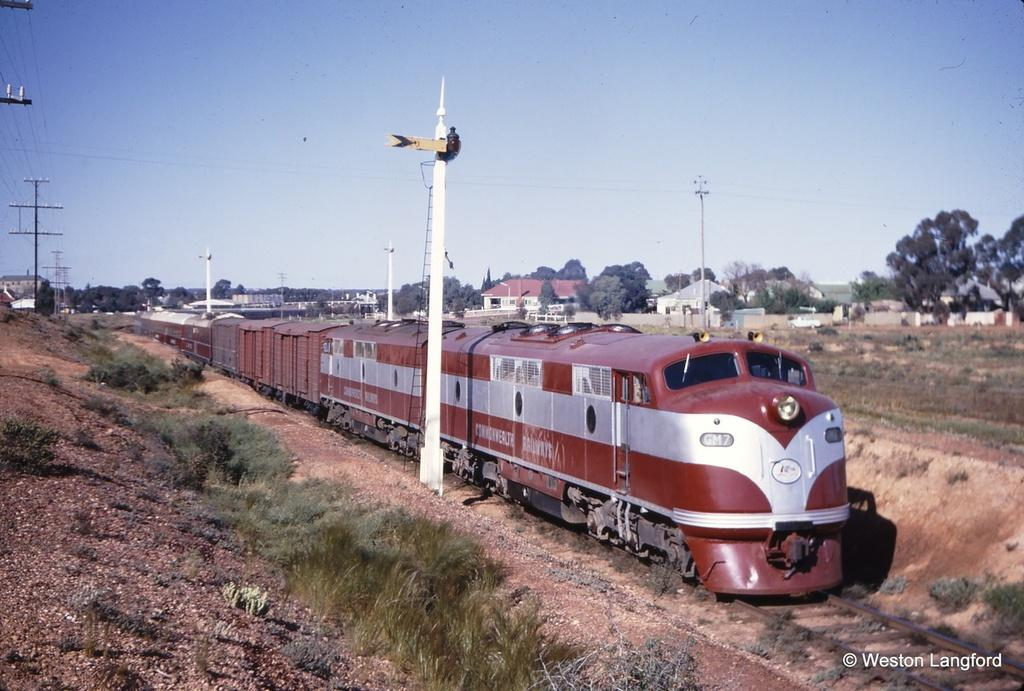What is the main subject in the center of the image? There is a red color train in the center of the image. What can be seen in the background of the image? There are houses and trees in the background of the image. What are the poles and wires in the image used for? The poles and wires in the image are likely used for supporting electrical or communication infrastructure. What organization is responsible for the train's voyage in the image? There is no information about the train's voyage or any organization in the image. 